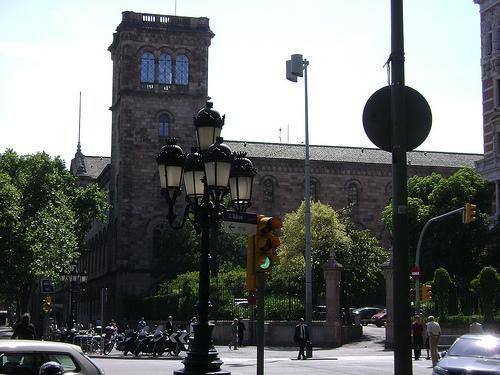How many cars are visible in the photo?
Give a very brief answer. 2. 